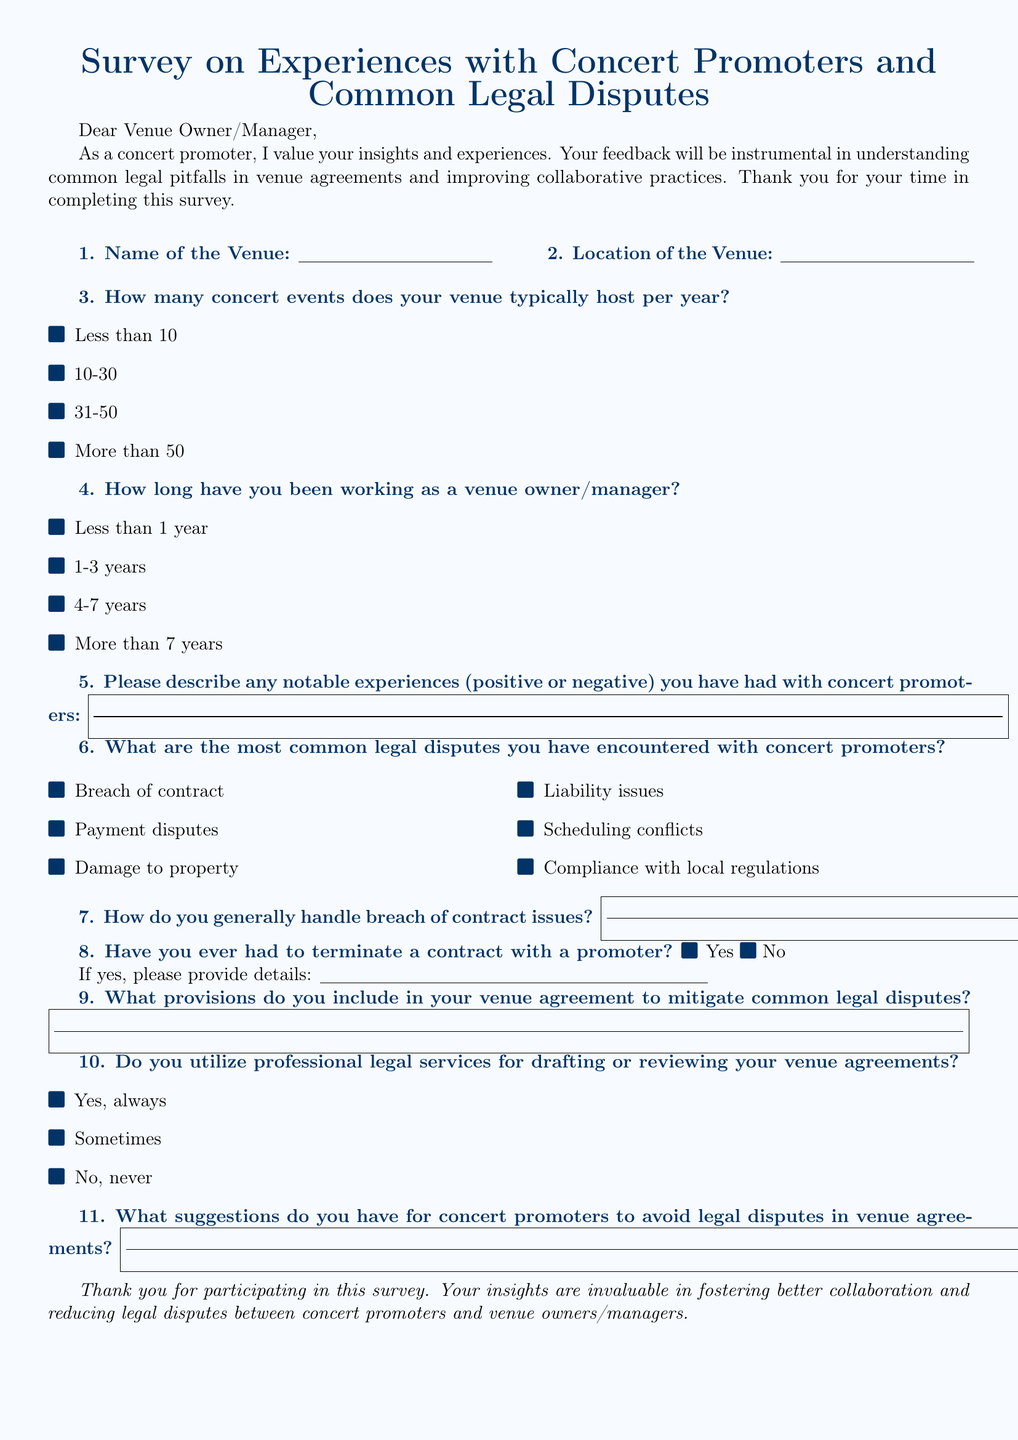what is the title of the survey? The title of the survey is presented at the top of the document in a large font.
Answer: Survey on Experiences with Concert Promoters and Common Legal Disputes how many concert events does your venue typically host per year? This question is presented as a multiple-choice option in the survey.
Answer: Less than 10, 10-30, 31-50, More than 50 what are the most common legal disputes encountered? This question lists several options related to legal disputes in the document.
Answer: Breach of contract, Payment disputes, Damage to property, Liability issues, Scheduling conflicts, Compliance with local regulations how do venue owners generally handle breach of contract issues? This question asks for a description and the answer can be found in a filled box.
Answer: (Answer will depend on the response given in the survey) has the venue ever terminated a contract with a promoter? This question is a binary yes/no option in the survey.
Answer: Yes or No what provisions should be included in venue agreements to mitigate disputes? This question prompts for recommended practices and answers will vary based on responses.
Answer: (Answer will depend on the response given in the survey) do venue owners utilize professional legal services for agreements? This question presents multiple-choice options regarding legal services usage.
Answer: Yes, always, Sometimes, No, never what suggestions are provided for concert promoters to avoid legal disputes? This question seeks suggestions and answers will vary.
Answer: (Answer will depend on the response given in the survey) 